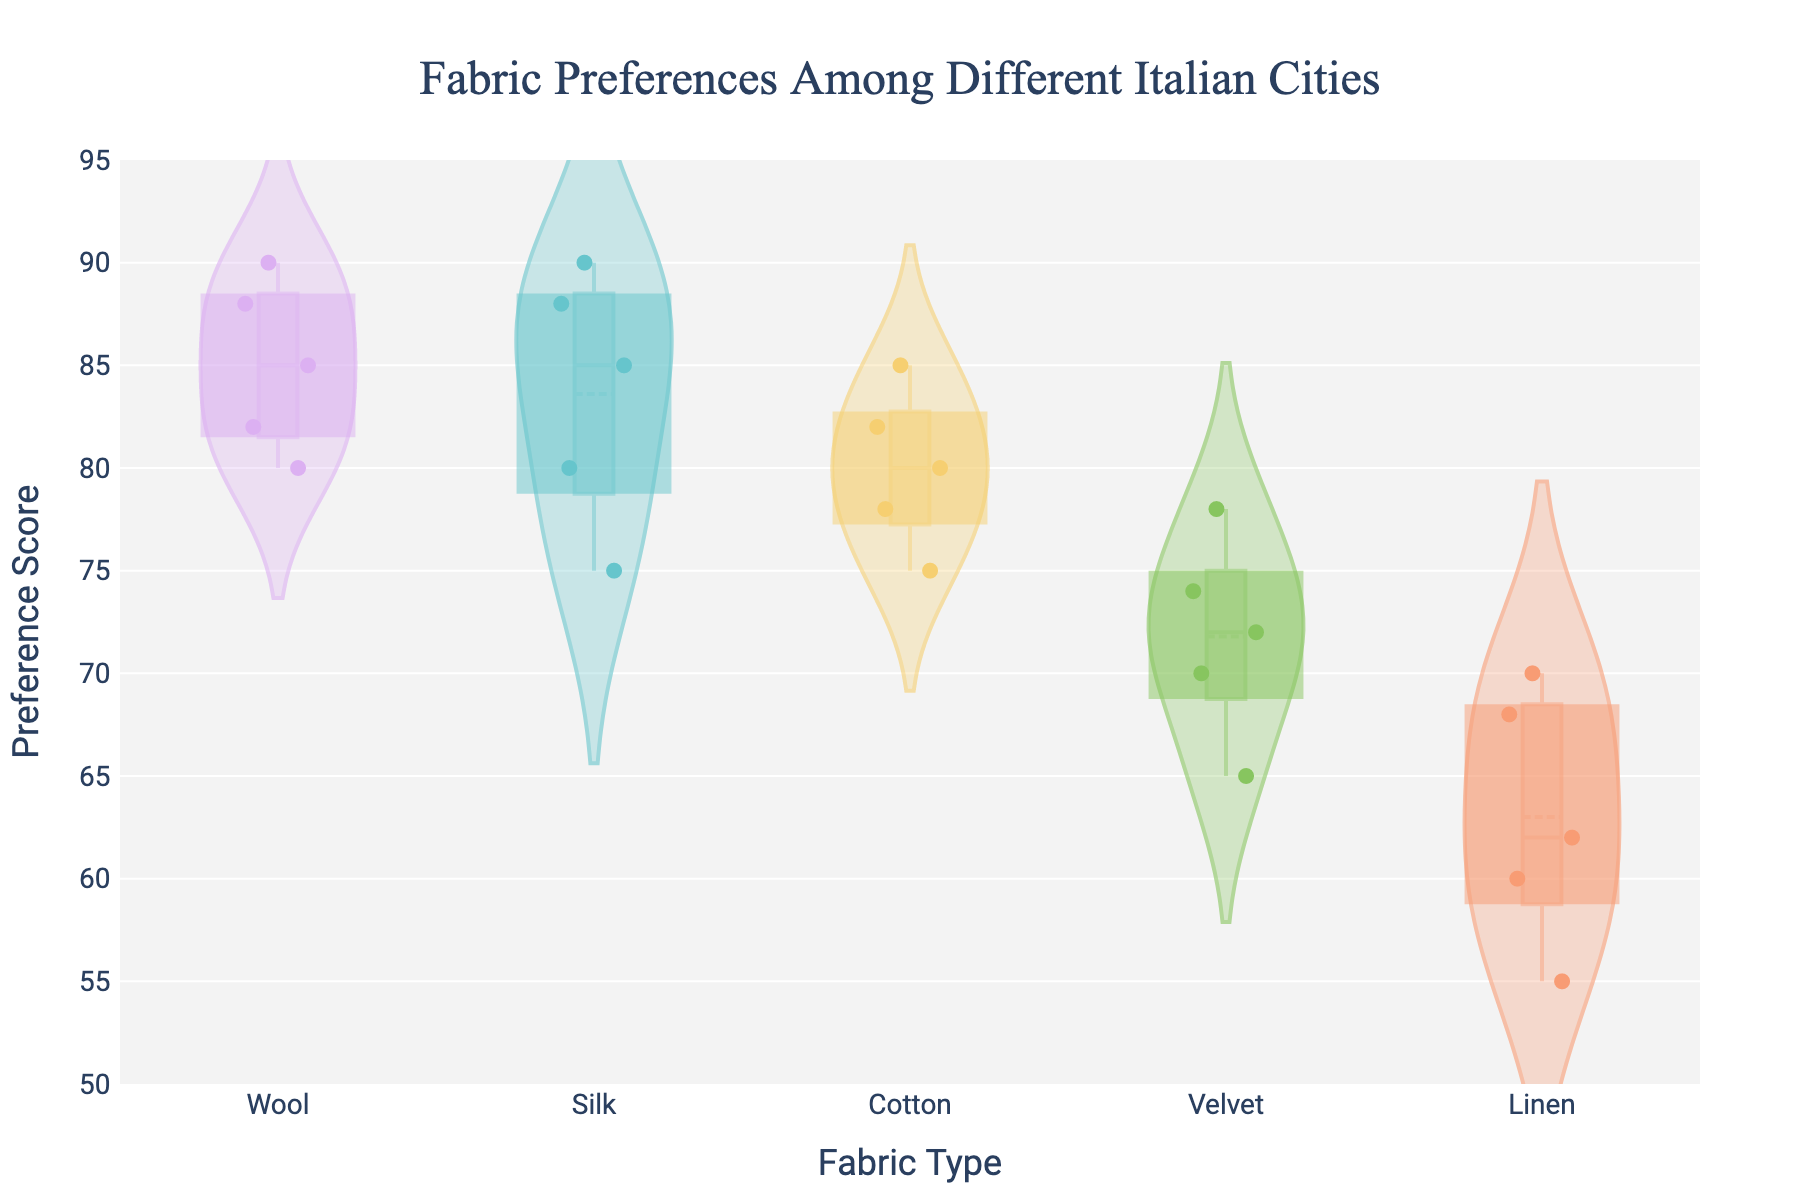What is the title of the plot? The title is located at the top of the plot and should be clear by visual inspection.
Answer: Fabric Preferences Among Different Italian Cities Which fabric type shows the highest mean preference score? The violin plot with the highest mean line indicates the fabric with the highest mean preference score.
Answer: Wool How does the preference for Silk compare between Venice and Rome? Look at the jittered points and the distribution of preference scores for Silk in both Venice and Rome. Compare the clustering and central tendency of the points.
Answer: Venice has higher preference scores for Silk than Rome Which city has the most varied preferences for Linen? Observe the width of the violin plots for Linen across the cities. The city with the widest plot shows the most variation.
Answer: Rome What is the range of preference scores for Velvet in Naples? Identify the jittered points and boundaries of Naples' Velvet violin plot. The range is from the lowest to highest points.
Answer: 64 to 74 Which fabric type has the smallest interquartile range (IQR) for Milan? The IQR is represented by the box inside the violin plot. Look for the shortest height of the box in Milan's fabric categories.
Answer: Linen Which fabric type in Florence shows the highest level of consistency in preference scores? Consistency can be interpreted as least variation. Look for the narrowest and most centralized violin plot among the fabrics.
Answer: Cotton Is the median preference score for Wool higher in Milan or Rome? Identify the median lines in the violin plots for Wool in Milan and Rome. Compare their positions on the y-axis.
Answer: Milan Are there any outliers in the preference scores for Cotton in Venice? Outliers are often marked by distinct points away from the main cluster. Check Venice's violin plot for Cotton for any such points.
Answer: No What is the overall preference trend for Velvet across all cities? Analyze the shapes of the violin plots and the distribution of points across all cities for Velvet. Summarize the general pattern.
Answer: Mixed preferences with moderate scores 